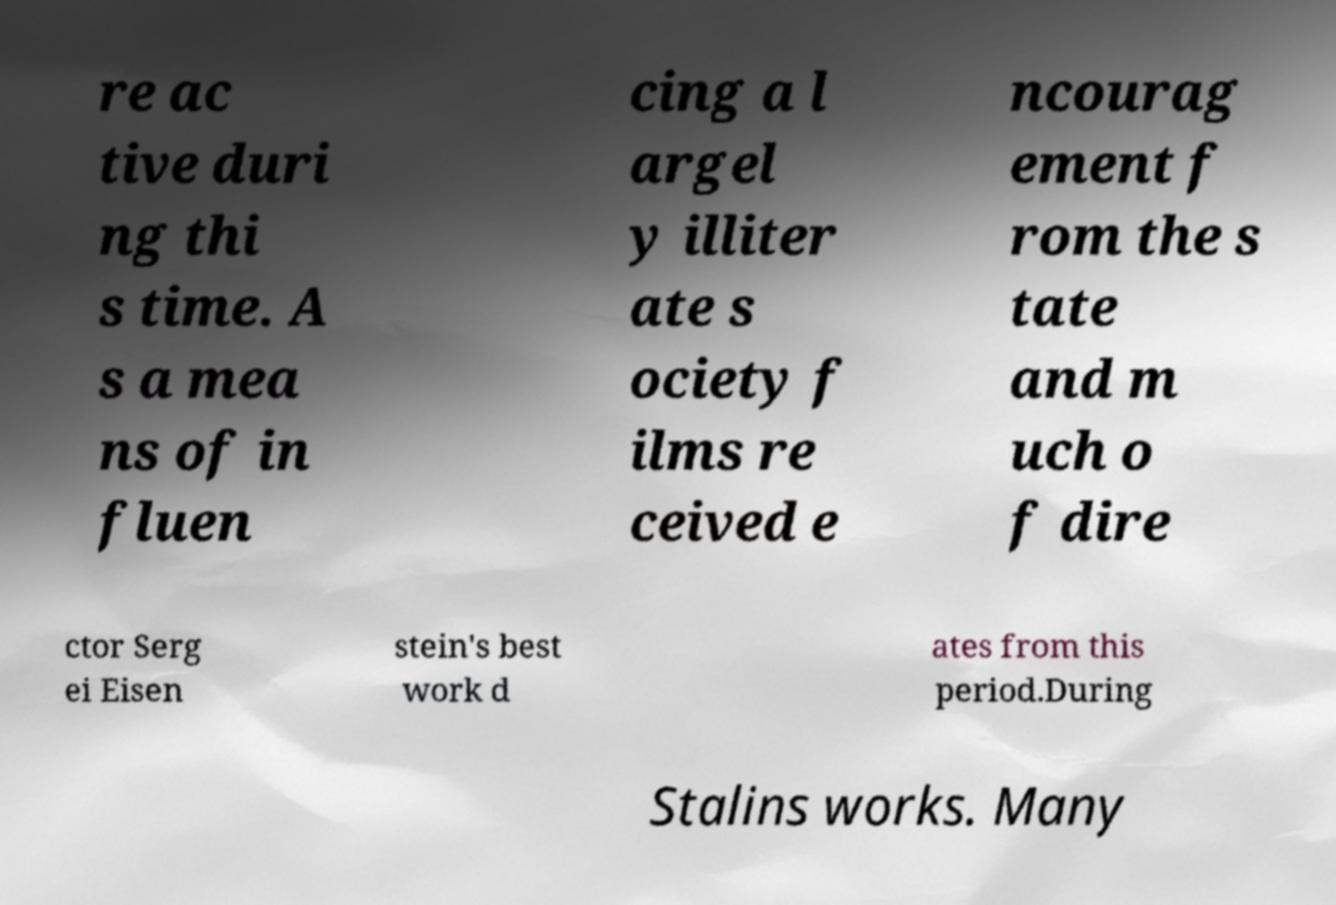Please identify and transcribe the text found in this image. re ac tive duri ng thi s time. A s a mea ns of in fluen cing a l argel y illiter ate s ociety f ilms re ceived e ncourag ement f rom the s tate and m uch o f dire ctor Serg ei Eisen stein's best work d ates from this period.During Stalins works. Many 